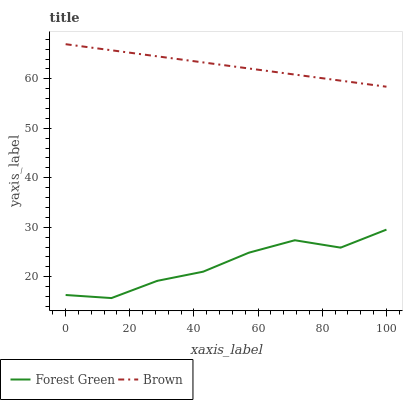Does Forest Green have the minimum area under the curve?
Answer yes or no. Yes. Does Brown have the maximum area under the curve?
Answer yes or no. Yes. Does Forest Green have the maximum area under the curve?
Answer yes or no. No. Is Brown the smoothest?
Answer yes or no. Yes. Is Forest Green the roughest?
Answer yes or no. Yes. Is Forest Green the smoothest?
Answer yes or no. No. Does Forest Green have the lowest value?
Answer yes or no. Yes. Does Brown have the highest value?
Answer yes or no. Yes. Does Forest Green have the highest value?
Answer yes or no. No. Is Forest Green less than Brown?
Answer yes or no. Yes. Is Brown greater than Forest Green?
Answer yes or no. Yes. Does Forest Green intersect Brown?
Answer yes or no. No. 